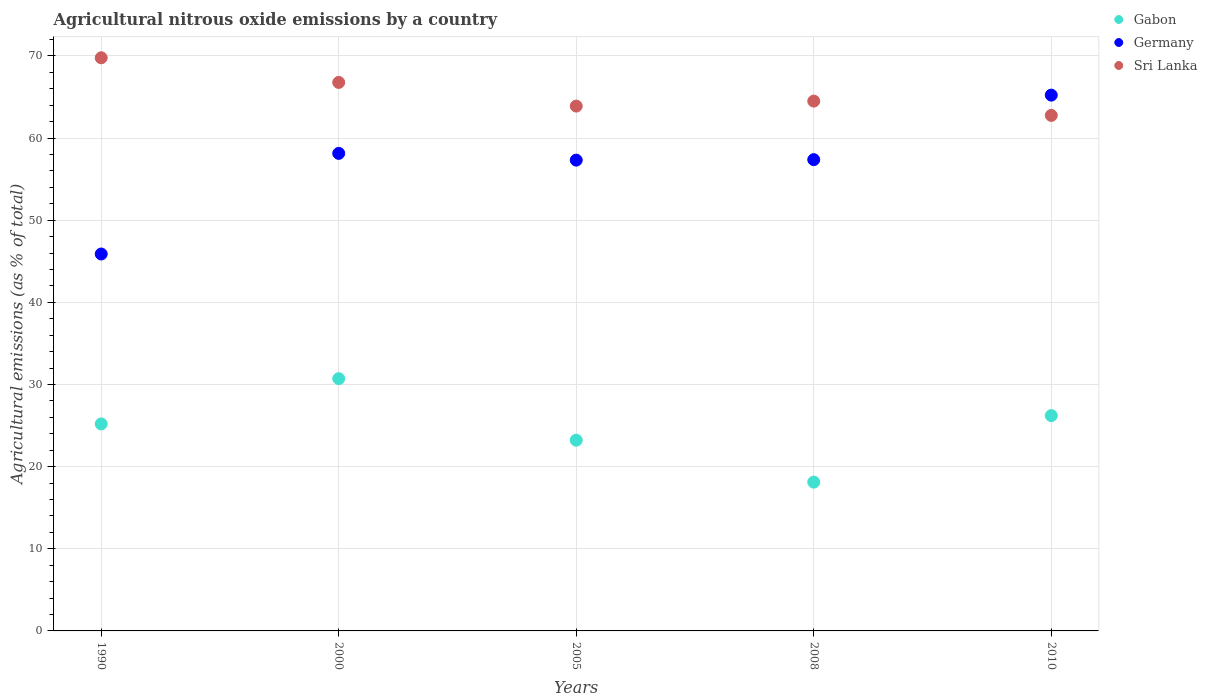How many different coloured dotlines are there?
Your response must be concise. 3. Is the number of dotlines equal to the number of legend labels?
Provide a succinct answer. Yes. What is the amount of agricultural nitrous oxide emitted in Sri Lanka in 2010?
Your answer should be compact. 62.77. Across all years, what is the maximum amount of agricultural nitrous oxide emitted in Germany?
Provide a short and direct response. 65.23. Across all years, what is the minimum amount of agricultural nitrous oxide emitted in Sri Lanka?
Make the answer very short. 62.77. In which year was the amount of agricultural nitrous oxide emitted in Sri Lanka maximum?
Your response must be concise. 1990. In which year was the amount of agricultural nitrous oxide emitted in Sri Lanka minimum?
Keep it short and to the point. 2010. What is the total amount of agricultural nitrous oxide emitted in Gabon in the graph?
Offer a very short reply. 123.48. What is the difference between the amount of agricultural nitrous oxide emitted in Sri Lanka in 2008 and that in 2010?
Make the answer very short. 1.74. What is the difference between the amount of agricultural nitrous oxide emitted in Germany in 1990 and the amount of agricultural nitrous oxide emitted in Gabon in 2010?
Offer a very short reply. 19.68. What is the average amount of agricultural nitrous oxide emitted in Germany per year?
Make the answer very short. 56.79. In the year 1990, what is the difference between the amount of agricultural nitrous oxide emitted in Sri Lanka and amount of agricultural nitrous oxide emitted in Germany?
Give a very brief answer. 23.89. In how many years, is the amount of agricultural nitrous oxide emitted in Germany greater than 36 %?
Your answer should be very brief. 5. What is the ratio of the amount of agricultural nitrous oxide emitted in Sri Lanka in 2000 to that in 2005?
Provide a short and direct response. 1.05. Is the amount of agricultural nitrous oxide emitted in Germany in 2005 less than that in 2010?
Ensure brevity in your answer.  Yes. Is the difference between the amount of agricultural nitrous oxide emitted in Sri Lanka in 2000 and 2005 greater than the difference between the amount of agricultural nitrous oxide emitted in Germany in 2000 and 2005?
Provide a short and direct response. Yes. What is the difference between the highest and the second highest amount of agricultural nitrous oxide emitted in Sri Lanka?
Provide a succinct answer. 3. What is the difference between the highest and the lowest amount of agricultural nitrous oxide emitted in Gabon?
Keep it short and to the point. 12.6. Is it the case that in every year, the sum of the amount of agricultural nitrous oxide emitted in Gabon and amount of agricultural nitrous oxide emitted in Sri Lanka  is greater than the amount of agricultural nitrous oxide emitted in Germany?
Ensure brevity in your answer.  Yes. Does the amount of agricultural nitrous oxide emitted in Gabon monotonically increase over the years?
Make the answer very short. No. What is the difference between two consecutive major ticks on the Y-axis?
Provide a short and direct response. 10. Are the values on the major ticks of Y-axis written in scientific E-notation?
Offer a very short reply. No. Does the graph contain grids?
Provide a succinct answer. Yes. Where does the legend appear in the graph?
Ensure brevity in your answer.  Top right. How many legend labels are there?
Offer a terse response. 3. How are the legend labels stacked?
Offer a very short reply. Vertical. What is the title of the graph?
Make the answer very short. Agricultural nitrous oxide emissions by a country. What is the label or title of the Y-axis?
Make the answer very short. Agricultural emissions (as % of total). What is the Agricultural emissions (as % of total) in Gabon in 1990?
Keep it short and to the point. 25.2. What is the Agricultural emissions (as % of total) in Germany in 1990?
Your response must be concise. 45.89. What is the Agricultural emissions (as % of total) in Sri Lanka in 1990?
Your answer should be compact. 69.78. What is the Agricultural emissions (as % of total) of Gabon in 2000?
Make the answer very short. 30.72. What is the Agricultural emissions (as % of total) of Germany in 2000?
Ensure brevity in your answer.  58.14. What is the Agricultural emissions (as % of total) in Sri Lanka in 2000?
Provide a short and direct response. 66.78. What is the Agricultural emissions (as % of total) of Gabon in 2005?
Offer a terse response. 23.22. What is the Agricultural emissions (as % of total) of Germany in 2005?
Offer a very short reply. 57.32. What is the Agricultural emissions (as % of total) of Sri Lanka in 2005?
Ensure brevity in your answer.  63.9. What is the Agricultural emissions (as % of total) in Gabon in 2008?
Provide a succinct answer. 18.12. What is the Agricultural emissions (as % of total) in Germany in 2008?
Provide a short and direct response. 57.38. What is the Agricultural emissions (as % of total) in Sri Lanka in 2008?
Offer a terse response. 64.51. What is the Agricultural emissions (as % of total) of Gabon in 2010?
Make the answer very short. 26.21. What is the Agricultural emissions (as % of total) in Germany in 2010?
Offer a terse response. 65.23. What is the Agricultural emissions (as % of total) of Sri Lanka in 2010?
Give a very brief answer. 62.77. Across all years, what is the maximum Agricultural emissions (as % of total) in Gabon?
Give a very brief answer. 30.72. Across all years, what is the maximum Agricultural emissions (as % of total) in Germany?
Make the answer very short. 65.23. Across all years, what is the maximum Agricultural emissions (as % of total) in Sri Lanka?
Keep it short and to the point. 69.78. Across all years, what is the minimum Agricultural emissions (as % of total) of Gabon?
Provide a succinct answer. 18.12. Across all years, what is the minimum Agricultural emissions (as % of total) in Germany?
Offer a very short reply. 45.89. Across all years, what is the minimum Agricultural emissions (as % of total) of Sri Lanka?
Your answer should be compact. 62.77. What is the total Agricultural emissions (as % of total) of Gabon in the graph?
Provide a succinct answer. 123.48. What is the total Agricultural emissions (as % of total) of Germany in the graph?
Your response must be concise. 283.97. What is the total Agricultural emissions (as % of total) of Sri Lanka in the graph?
Your answer should be very brief. 327.73. What is the difference between the Agricultural emissions (as % of total) of Gabon in 1990 and that in 2000?
Offer a terse response. -5.51. What is the difference between the Agricultural emissions (as % of total) of Germany in 1990 and that in 2000?
Keep it short and to the point. -12.25. What is the difference between the Agricultural emissions (as % of total) of Sri Lanka in 1990 and that in 2000?
Your answer should be compact. 3. What is the difference between the Agricultural emissions (as % of total) of Gabon in 1990 and that in 2005?
Offer a very short reply. 1.98. What is the difference between the Agricultural emissions (as % of total) of Germany in 1990 and that in 2005?
Keep it short and to the point. -11.43. What is the difference between the Agricultural emissions (as % of total) in Sri Lanka in 1990 and that in 2005?
Your response must be concise. 5.88. What is the difference between the Agricultural emissions (as % of total) in Gabon in 1990 and that in 2008?
Make the answer very short. 7.09. What is the difference between the Agricultural emissions (as % of total) of Germany in 1990 and that in 2008?
Provide a short and direct response. -11.49. What is the difference between the Agricultural emissions (as % of total) in Sri Lanka in 1990 and that in 2008?
Your response must be concise. 5.27. What is the difference between the Agricultural emissions (as % of total) in Gabon in 1990 and that in 2010?
Give a very brief answer. -1.01. What is the difference between the Agricultural emissions (as % of total) in Germany in 1990 and that in 2010?
Make the answer very short. -19.34. What is the difference between the Agricultural emissions (as % of total) in Sri Lanka in 1990 and that in 2010?
Give a very brief answer. 7.01. What is the difference between the Agricultural emissions (as % of total) of Gabon in 2000 and that in 2005?
Offer a very short reply. 7.49. What is the difference between the Agricultural emissions (as % of total) in Germany in 2000 and that in 2005?
Your answer should be compact. 0.82. What is the difference between the Agricultural emissions (as % of total) in Sri Lanka in 2000 and that in 2005?
Ensure brevity in your answer.  2.88. What is the difference between the Agricultural emissions (as % of total) in Gabon in 2000 and that in 2008?
Give a very brief answer. 12.6. What is the difference between the Agricultural emissions (as % of total) of Germany in 2000 and that in 2008?
Give a very brief answer. 0.76. What is the difference between the Agricultural emissions (as % of total) in Sri Lanka in 2000 and that in 2008?
Your response must be concise. 2.27. What is the difference between the Agricultural emissions (as % of total) in Gabon in 2000 and that in 2010?
Offer a terse response. 4.5. What is the difference between the Agricultural emissions (as % of total) in Germany in 2000 and that in 2010?
Offer a very short reply. -7.09. What is the difference between the Agricultural emissions (as % of total) in Sri Lanka in 2000 and that in 2010?
Provide a short and direct response. 4.01. What is the difference between the Agricultural emissions (as % of total) of Gabon in 2005 and that in 2008?
Ensure brevity in your answer.  5.11. What is the difference between the Agricultural emissions (as % of total) in Germany in 2005 and that in 2008?
Ensure brevity in your answer.  -0.06. What is the difference between the Agricultural emissions (as % of total) of Sri Lanka in 2005 and that in 2008?
Your answer should be very brief. -0.61. What is the difference between the Agricultural emissions (as % of total) in Gabon in 2005 and that in 2010?
Your response must be concise. -2.99. What is the difference between the Agricultural emissions (as % of total) in Germany in 2005 and that in 2010?
Keep it short and to the point. -7.91. What is the difference between the Agricultural emissions (as % of total) of Sri Lanka in 2005 and that in 2010?
Provide a short and direct response. 1.13. What is the difference between the Agricultural emissions (as % of total) in Gabon in 2008 and that in 2010?
Offer a terse response. -8.1. What is the difference between the Agricultural emissions (as % of total) of Germany in 2008 and that in 2010?
Provide a succinct answer. -7.86. What is the difference between the Agricultural emissions (as % of total) of Sri Lanka in 2008 and that in 2010?
Your response must be concise. 1.74. What is the difference between the Agricultural emissions (as % of total) in Gabon in 1990 and the Agricultural emissions (as % of total) in Germany in 2000?
Make the answer very short. -32.94. What is the difference between the Agricultural emissions (as % of total) in Gabon in 1990 and the Agricultural emissions (as % of total) in Sri Lanka in 2000?
Your answer should be compact. -41.58. What is the difference between the Agricultural emissions (as % of total) of Germany in 1990 and the Agricultural emissions (as % of total) of Sri Lanka in 2000?
Your answer should be compact. -20.89. What is the difference between the Agricultural emissions (as % of total) in Gabon in 1990 and the Agricultural emissions (as % of total) in Germany in 2005?
Provide a succinct answer. -32.12. What is the difference between the Agricultural emissions (as % of total) in Gabon in 1990 and the Agricultural emissions (as % of total) in Sri Lanka in 2005?
Keep it short and to the point. -38.7. What is the difference between the Agricultural emissions (as % of total) in Germany in 1990 and the Agricultural emissions (as % of total) in Sri Lanka in 2005?
Offer a very short reply. -18.01. What is the difference between the Agricultural emissions (as % of total) of Gabon in 1990 and the Agricultural emissions (as % of total) of Germany in 2008?
Your answer should be very brief. -32.18. What is the difference between the Agricultural emissions (as % of total) in Gabon in 1990 and the Agricultural emissions (as % of total) in Sri Lanka in 2008?
Your answer should be very brief. -39.3. What is the difference between the Agricultural emissions (as % of total) in Germany in 1990 and the Agricultural emissions (as % of total) in Sri Lanka in 2008?
Make the answer very short. -18.62. What is the difference between the Agricultural emissions (as % of total) of Gabon in 1990 and the Agricultural emissions (as % of total) of Germany in 2010?
Provide a succinct answer. -40.03. What is the difference between the Agricultural emissions (as % of total) of Gabon in 1990 and the Agricultural emissions (as % of total) of Sri Lanka in 2010?
Your response must be concise. -37.56. What is the difference between the Agricultural emissions (as % of total) in Germany in 1990 and the Agricultural emissions (as % of total) in Sri Lanka in 2010?
Make the answer very short. -16.87. What is the difference between the Agricultural emissions (as % of total) in Gabon in 2000 and the Agricultural emissions (as % of total) in Germany in 2005?
Ensure brevity in your answer.  -26.6. What is the difference between the Agricultural emissions (as % of total) in Gabon in 2000 and the Agricultural emissions (as % of total) in Sri Lanka in 2005?
Your answer should be very brief. -33.18. What is the difference between the Agricultural emissions (as % of total) of Germany in 2000 and the Agricultural emissions (as % of total) of Sri Lanka in 2005?
Keep it short and to the point. -5.76. What is the difference between the Agricultural emissions (as % of total) in Gabon in 2000 and the Agricultural emissions (as % of total) in Germany in 2008?
Offer a very short reply. -26.66. What is the difference between the Agricultural emissions (as % of total) in Gabon in 2000 and the Agricultural emissions (as % of total) in Sri Lanka in 2008?
Your answer should be compact. -33.79. What is the difference between the Agricultural emissions (as % of total) of Germany in 2000 and the Agricultural emissions (as % of total) of Sri Lanka in 2008?
Your response must be concise. -6.36. What is the difference between the Agricultural emissions (as % of total) of Gabon in 2000 and the Agricultural emissions (as % of total) of Germany in 2010?
Keep it short and to the point. -34.52. What is the difference between the Agricultural emissions (as % of total) of Gabon in 2000 and the Agricultural emissions (as % of total) of Sri Lanka in 2010?
Provide a succinct answer. -32.05. What is the difference between the Agricultural emissions (as % of total) of Germany in 2000 and the Agricultural emissions (as % of total) of Sri Lanka in 2010?
Keep it short and to the point. -4.62. What is the difference between the Agricultural emissions (as % of total) of Gabon in 2005 and the Agricultural emissions (as % of total) of Germany in 2008?
Make the answer very short. -34.16. What is the difference between the Agricultural emissions (as % of total) of Gabon in 2005 and the Agricultural emissions (as % of total) of Sri Lanka in 2008?
Your response must be concise. -41.28. What is the difference between the Agricultural emissions (as % of total) in Germany in 2005 and the Agricultural emissions (as % of total) in Sri Lanka in 2008?
Offer a terse response. -7.19. What is the difference between the Agricultural emissions (as % of total) of Gabon in 2005 and the Agricultural emissions (as % of total) of Germany in 2010?
Your answer should be compact. -42.01. What is the difference between the Agricultural emissions (as % of total) of Gabon in 2005 and the Agricultural emissions (as % of total) of Sri Lanka in 2010?
Offer a very short reply. -39.54. What is the difference between the Agricultural emissions (as % of total) of Germany in 2005 and the Agricultural emissions (as % of total) of Sri Lanka in 2010?
Provide a succinct answer. -5.44. What is the difference between the Agricultural emissions (as % of total) in Gabon in 2008 and the Agricultural emissions (as % of total) in Germany in 2010?
Make the answer very short. -47.12. What is the difference between the Agricultural emissions (as % of total) of Gabon in 2008 and the Agricultural emissions (as % of total) of Sri Lanka in 2010?
Keep it short and to the point. -44.65. What is the difference between the Agricultural emissions (as % of total) in Germany in 2008 and the Agricultural emissions (as % of total) in Sri Lanka in 2010?
Provide a short and direct response. -5.39. What is the average Agricultural emissions (as % of total) of Gabon per year?
Offer a very short reply. 24.7. What is the average Agricultural emissions (as % of total) of Germany per year?
Your answer should be very brief. 56.79. What is the average Agricultural emissions (as % of total) in Sri Lanka per year?
Offer a terse response. 65.55. In the year 1990, what is the difference between the Agricultural emissions (as % of total) of Gabon and Agricultural emissions (as % of total) of Germany?
Provide a short and direct response. -20.69. In the year 1990, what is the difference between the Agricultural emissions (as % of total) of Gabon and Agricultural emissions (as % of total) of Sri Lanka?
Offer a terse response. -44.58. In the year 1990, what is the difference between the Agricultural emissions (as % of total) of Germany and Agricultural emissions (as % of total) of Sri Lanka?
Your response must be concise. -23.89. In the year 2000, what is the difference between the Agricultural emissions (as % of total) of Gabon and Agricultural emissions (as % of total) of Germany?
Make the answer very short. -27.42. In the year 2000, what is the difference between the Agricultural emissions (as % of total) in Gabon and Agricultural emissions (as % of total) in Sri Lanka?
Make the answer very short. -36.06. In the year 2000, what is the difference between the Agricultural emissions (as % of total) of Germany and Agricultural emissions (as % of total) of Sri Lanka?
Provide a short and direct response. -8.64. In the year 2005, what is the difference between the Agricultural emissions (as % of total) in Gabon and Agricultural emissions (as % of total) in Germany?
Your answer should be very brief. -34.1. In the year 2005, what is the difference between the Agricultural emissions (as % of total) in Gabon and Agricultural emissions (as % of total) in Sri Lanka?
Make the answer very short. -40.67. In the year 2005, what is the difference between the Agricultural emissions (as % of total) of Germany and Agricultural emissions (as % of total) of Sri Lanka?
Your answer should be very brief. -6.58. In the year 2008, what is the difference between the Agricultural emissions (as % of total) in Gabon and Agricultural emissions (as % of total) in Germany?
Give a very brief answer. -39.26. In the year 2008, what is the difference between the Agricultural emissions (as % of total) in Gabon and Agricultural emissions (as % of total) in Sri Lanka?
Keep it short and to the point. -46.39. In the year 2008, what is the difference between the Agricultural emissions (as % of total) of Germany and Agricultural emissions (as % of total) of Sri Lanka?
Your answer should be compact. -7.13. In the year 2010, what is the difference between the Agricultural emissions (as % of total) in Gabon and Agricultural emissions (as % of total) in Germany?
Provide a short and direct response. -39.02. In the year 2010, what is the difference between the Agricultural emissions (as % of total) in Gabon and Agricultural emissions (as % of total) in Sri Lanka?
Provide a short and direct response. -36.55. In the year 2010, what is the difference between the Agricultural emissions (as % of total) in Germany and Agricultural emissions (as % of total) in Sri Lanka?
Make the answer very short. 2.47. What is the ratio of the Agricultural emissions (as % of total) in Gabon in 1990 to that in 2000?
Offer a terse response. 0.82. What is the ratio of the Agricultural emissions (as % of total) of Germany in 1990 to that in 2000?
Give a very brief answer. 0.79. What is the ratio of the Agricultural emissions (as % of total) of Sri Lanka in 1990 to that in 2000?
Ensure brevity in your answer.  1.04. What is the ratio of the Agricultural emissions (as % of total) of Gabon in 1990 to that in 2005?
Keep it short and to the point. 1.09. What is the ratio of the Agricultural emissions (as % of total) of Germany in 1990 to that in 2005?
Your answer should be compact. 0.8. What is the ratio of the Agricultural emissions (as % of total) in Sri Lanka in 1990 to that in 2005?
Make the answer very short. 1.09. What is the ratio of the Agricultural emissions (as % of total) in Gabon in 1990 to that in 2008?
Provide a short and direct response. 1.39. What is the ratio of the Agricultural emissions (as % of total) in Germany in 1990 to that in 2008?
Offer a very short reply. 0.8. What is the ratio of the Agricultural emissions (as % of total) of Sri Lanka in 1990 to that in 2008?
Your answer should be very brief. 1.08. What is the ratio of the Agricultural emissions (as % of total) in Gabon in 1990 to that in 2010?
Keep it short and to the point. 0.96. What is the ratio of the Agricultural emissions (as % of total) of Germany in 1990 to that in 2010?
Your answer should be compact. 0.7. What is the ratio of the Agricultural emissions (as % of total) in Sri Lanka in 1990 to that in 2010?
Your answer should be very brief. 1.11. What is the ratio of the Agricultural emissions (as % of total) in Gabon in 2000 to that in 2005?
Ensure brevity in your answer.  1.32. What is the ratio of the Agricultural emissions (as % of total) in Germany in 2000 to that in 2005?
Ensure brevity in your answer.  1.01. What is the ratio of the Agricultural emissions (as % of total) in Sri Lanka in 2000 to that in 2005?
Offer a very short reply. 1.05. What is the ratio of the Agricultural emissions (as % of total) in Gabon in 2000 to that in 2008?
Provide a short and direct response. 1.7. What is the ratio of the Agricultural emissions (as % of total) of Germany in 2000 to that in 2008?
Keep it short and to the point. 1.01. What is the ratio of the Agricultural emissions (as % of total) in Sri Lanka in 2000 to that in 2008?
Make the answer very short. 1.04. What is the ratio of the Agricultural emissions (as % of total) of Gabon in 2000 to that in 2010?
Offer a very short reply. 1.17. What is the ratio of the Agricultural emissions (as % of total) in Germany in 2000 to that in 2010?
Keep it short and to the point. 0.89. What is the ratio of the Agricultural emissions (as % of total) in Sri Lanka in 2000 to that in 2010?
Keep it short and to the point. 1.06. What is the ratio of the Agricultural emissions (as % of total) of Gabon in 2005 to that in 2008?
Offer a terse response. 1.28. What is the ratio of the Agricultural emissions (as % of total) in Germany in 2005 to that in 2008?
Ensure brevity in your answer.  1. What is the ratio of the Agricultural emissions (as % of total) of Sri Lanka in 2005 to that in 2008?
Your answer should be very brief. 0.99. What is the ratio of the Agricultural emissions (as % of total) of Gabon in 2005 to that in 2010?
Your response must be concise. 0.89. What is the ratio of the Agricultural emissions (as % of total) in Germany in 2005 to that in 2010?
Give a very brief answer. 0.88. What is the ratio of the Agricultural emissions (as % of total) of Sri Lanka in 2005 to that in 2010?
Provide a succinct answer. 1.02. What is the ratio of the Agricultural emissions (as % of total) of Gabon in 2008 to that in 2010?
Give a very brief answer. 0.69. What is the ratio of the Agricultural emissions (as % of total) in Germany in 2008 to that in 2010?
Your answer should be very brief. 0.88. What is the ratio of the Agricultural emissions (as % of total) of Sri Lanka in 2008 to that in 2010?
Make the answer very short. 1.03. What is the difference between the highest and the second highest Agricultural emissions (as % of total) in Gabon?
Your answer should be compact. 4.5. What is the difference between the highest and the second highest Agricultural emissions (as % of total) of Germany?
Your response must be concise. 7.09. What is the difference between the highest and the second highest Agricultural emissions (as % of total) of Sri Lanka?
Keep it short and to the point. 3. What is the difference between the highest and the lowest Agricultural emissions (as % of total) of Gabon?
Your answer should be compact. 12.6. What is the difference between the highest and the lowest Agricultural emissions (as % of total) of Germany?
Your answer should be very brief. 19.34. What is the difference between the highest and the lowest Agricultural emissions (as % of total) of Sri Lanka?
Your answer should be very brief. 7.01. 